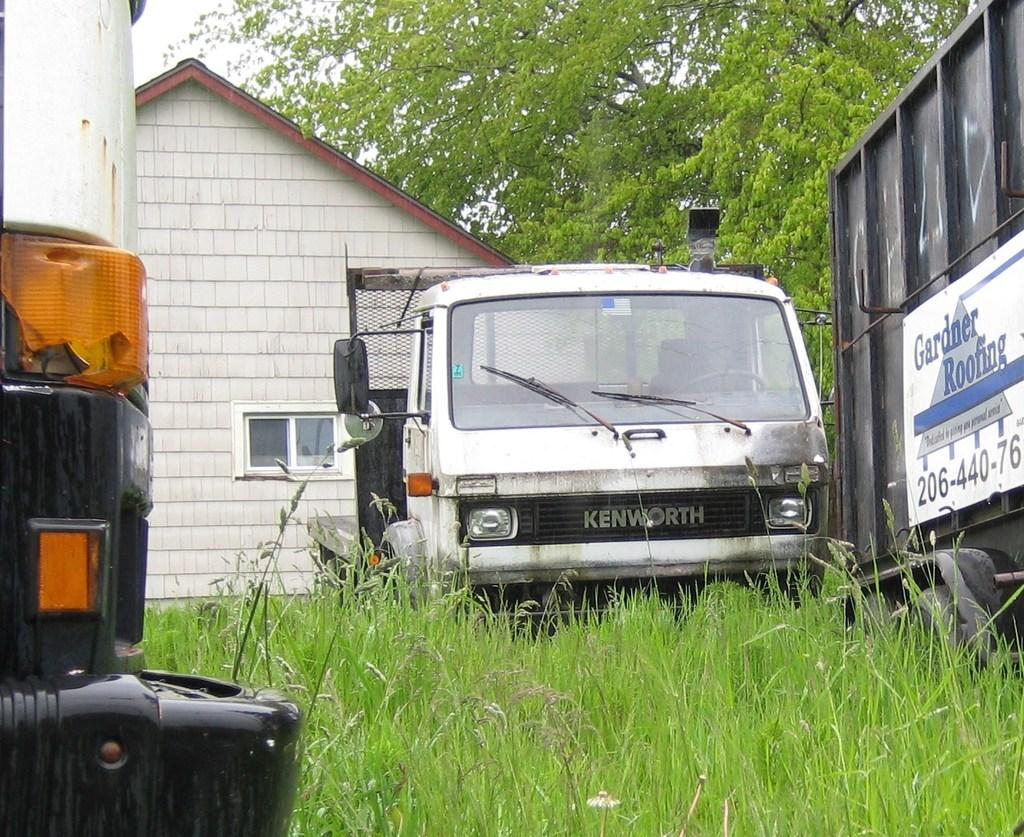<image>
Render a clear and concise summary of the photo. Blue and white sign for Gardner ROofing outdoors. 